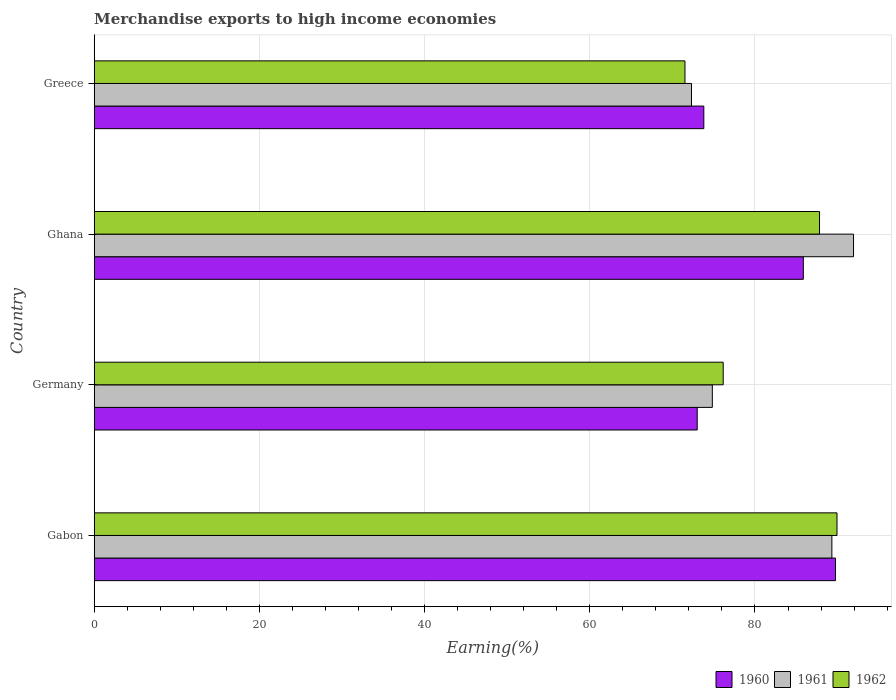What is the percentage of amount earned from merchandise exports in 1961 in Ghana?
Offer a very short reply. 91.93. Across all countries, what is the maximum percentage of amount earned from merchandise exports in 1962?
Provide a succinct answer. 89.93. Across all countries, what is the minimum percentage of amount earned from merchandise exports in 1961?
Your answer should be very brief. 72.31. In which country was the percentage of amount earned from merchandise exports in 1960 maximum?
Offer a very short reply. Gabon. What is the total percentage of amount earned from merchandise exports in 1960 in the graph?
Provide a short and direct response. 322.42. What is the difference between the percentage of amount earned from merchandise exports in 1960 in Germany and that in Greece?
Your answer should be compact. -0.8. What is the difference between the percentage of amount earned from merchandise exports in 1960 in Ghana and the percentage of amount earned from merchandise exports in 1961 in Gabon?
Offer a terse response. -3.46. What is the average percentage of amount earned from merchandise exports in 1962 per country?
Make the answer very short. 81.36. What is the difference between the percentage of amount earned from merchandise exports in 1960 and percentage of amount earned from merchandise exports in 1962 in Greece?
Provide a succinct answer. 2.28. In how many countries, is the percentage of amount earned from merchandise exports in 1961 greater than 28 %?
Provide a short and direct response. 4. What is the ratio of the percentage of amount earned from merchandise exports in 1962 in Germany to that in Ghana?
Provide a succinct answer. 0.87. Is the percentage of amount earned from merchandise exports in 1960 in Gabon less than that in Germany?
Your response must be concise. No. What is the difference between the highest and the second highest percentage of amount earned from merchandise exports in 1961?
Provide a succinct answer. 2.62. What is the difference between the highest and the lowest percentage of amount earned from merchandise exports in 1962?
Offer a terse response. 18.41. In how many countries, is the percentage of amount earned from merchandise exports in 1962 greater than the average percentage of amount earned from merchandise exports in 1962 taken over all countries?
Offer a terse response. 2. What does the 2nd bar from the bottom in Gabon represents?
Ensure brevity in your answer.  1961. Is it the case that in every country, the sum of the percentage of amount earned from merchandise exports in 1962 and percentage of amount earned from merchandise exports in 1961 is greater than the percentage of amount earned from merchandise exports in 1960?
Your response must be concise. Yes. How many bars are there?
Your answer should be very brief. 12. How many countries are there in the graph?
Keep it short and to the point. 4. How many legend labels are there?
Your answer should be very brief. 3. What is the title of the graph?
Make the answer very short. Merchandise exports to high income economies. What is the label or title of the X-axis?
Make the answer very short. Earning(%). What is the label or title of the Y-axis?
Provide a succinct answer. Country. What is the Earning(%) in 1960 in Gabon?
Make the answer very short. 89.75. What is the Earning(%) in 1961 in Gabon?
Your response must be concise. 89.31. What is the Earning(%) in 1962 in Gabon?
Your answer should be very brief. 89.93. What is the Earning(%) of 1960 in Germany?
Your answer should be very brief. 73.01. What is the Earning(%) of 1961 in Germany?
Give a very brief answer. 74.84. What is the Earning(%) of 1962 in Germany?
Your answer should be compact. 76.15. What is the Earning(%) in 1960 in Ghana?
Ensure brevity in your answer.  85.85. What is the Earning(%) in 1961 in Ghana?
Keep it short and to the point. 91.93. What is the Earning(%) in 1962 in Ghana?
Offer a terse response. 87.82. What is the Earning(%) of 1960 in Greece?
Offer a very short reply. 73.81. What is the Earning(%) of 1961 in Greece?
Provide a succinct answer. 72.31. What is the Earning(%) of 1962 in Greece?
Provide a succinct answer. 71.53. Across all countries, what is the maximum Earning(%) of 1960?
Provide a short and direct response. 89.75. Across all countries, what is the maximum Earning(%) in 1961?
Provide a succinct answer. 91.93. Across all countries, what is the maximum Earning(%) of 1962?
Provide a succinct answer. 89.93. Across all countries, what is the minimum Earning(%) in 1960?
Ensure brevity in your answer.  73.01. Across all countries, what is the minimum Earning(%) in 1961?
Ensure brevity in your answer.  72.31. Across all countries, what is the minimum Earning(%) in 1962?
Provide a short and direct response. 71.53. What is the total Earning(%) of 1960 in the graph?
Provide a succinct answer. 322.42. What is the total Earning(%) of 1961 in the graph?
Give a very brief answer. 328.4. What is the total Earning(%) of 1962 in the graph?
Provide a succinct answer. 325.43. What is the difference between the Earning(%) of 1960 in Gabon and that in Germany?
Make the answer very short. 16.74. What is the difference between the Earning(%) in 1961 in Gabon and that in Germany?
Your response must be concise. 14.47. What is the difference between the Earning(%) of 1962 in Gabon and that in Germany?
Offer a terse response. 13.78. What is the difference between the Earning(%) of 1960 in Gabon and that in Ghana?
Give a very brief answer. 3.89. What is the difference between the Earning(%) of 1961 in Gabon and that in Ghana?
Your answer should be very brief. -2.62. What is the difference between the Earning(%) of 1962 in Gabon and that in Ghana?
Your answer should be compact. 2.11. What is the difference between the Earning(%) of 1960 in Gabon and that in Greece?
Keep it short and to the point. 15.94. What is the difference between the Earning(%) of 1961 in Gabon and that in Greece?
Your response must be concise. 17. What is the difference between the Earning(%) of 1962 in Gabon and that in Greece?
Keep it short and to the point. 18.41. What is the difference between the Earning(%) of 1960 in Germany and that in Ghana?
Provide a succinct answer. -12.85. What is the difference between the Earning(%) of 1961 in Germany and that in Ghana?
Keep it short and to the point. -17.09. What is the difference between the Earning(%) of 1962 in Germany and that in Ghana?
Keep it short and to the point. -11.66. What is the difference between the Earning(%) in 1960 in Germany and that in Greece?
Ensure brevity in your answer.  -0.8. What is the difference between the Earning(%) of 1961 in Germany and that in Greece?
Your answer should be compact. 2.52. What is the difference between the Earning(%) in 1962 in Germany and that in Greece?
Offer a very short reply. 4.63. What is the difference between the Earning(%) in 1960 in Ghana and that in Greece?
Your answer should be very brief. 12.05. What is the difference between the Earning(%) in 1961 in Ghana and that in Greece?
Provide a short and direct response. 19.62. What is the difference between the Earning(%) in 1962 in Ghana and that in Greece?
Your answer should be very brief. 16.29. What is the difference between the Earning(%) of 1960 in Gabon and the Earning(%) of 1961 in Germany?
Your answer should be very brief. 14.91. What is the difference between the Earning(%) of 1960 in Gabon and the Earning(%) of 1962 in Germany?
Provide a succinct answer. 13.59. What is the difference between the Earning(%) of 1961 in Gabon and the Earning(%) of 1962 in Germany?
Keep it short and to the point. 13.16. What is the difference between the Earning(%) of 1960 in Gabon and the Earning(%) of 1961 in Ghana?
Provide a short and direct response. -2.18. What is the difference between the Earning(%) in 1960 in Gabon and the Earning(%) in 1962 in Ghana?
Offer a very short reply. 1.93. What is the difference between the Earning(%) of 1961 in Gabon and the Earning(%) of 1962 in Ghana?
Make the answer very short. 1.49. What is the difference between the Earning(%) in 1960 in Gabon and the Earning(%) in 1961 in Greece?
Keep it short and to the point. 17.43. What is the difference between the Earning(%) of 1960 in Gabon and the Earning(%) of 1962 in Greece?
Your answer should be compact. 18.22. What is the difference between the Earning(%) in 1961 in Gabon and the Earning(%) in 1962 in Greece?
Give a very brief answer. 17.79. What is the difference between the Earning(%) in 1960 in Germany and the Earning(%) in 1961 in Ghana?
Ensure brevity in your answer.  -18.93. What is the difference between the Earning(%) in 1960 in Germany and the Earning(%) in 1962 in Ghana?
Your answer should be very brief. -14.81. What is the difference between the Earning(%) of 1961 in Germany and the Earning(%) of 1962 in Ghana?
Ensure brevity in your answer.  -12.98. What is the difference between the Earning(%) of 1960 in Germany and the Earning(%) of 1961 in Greece?
Your answer should be very brief. 0.69. What is the difference between the Earning(%) of 1960 in Germany and the Earning(%) of 1962 in Greece?
Provide a short and direct response. 1.48. What is the difference between the Earning(%) of 1961 in Germany and the Earning(%) of 1962 in Greece?
Offer a very short reply. 3.31. What is the difference between the Earning(%) of 1960 in Ghana and the Earning(%) of 1961 in Greece?
Your answer should be compact. 13.54. What is the difference between the Earning(%) in 1960 in Ghana and the Earning(%) in 1962 in Greece?
Give a very brief answer. 14.33. What is the difference between the Earning(%) in 1961 in Ghana and the Earning(%) in 1962 in Greece?
Your response must be concise. 20.41. What is the average Earning(%) in 1960 per country?
Make the answer very short. 80.6. What is the average Earning(%) in 1961 per country?
Make the answer very short. 82.1. What is the average Earning(%) in 1962 per country?
Your answer should be very brief. 81.36. What is the difference between the Earning(%) of 1960 and Earning(%) of 1961 in Gabon?
Keep it short and to the point. 0.44. What is the difference between the Earning(%) in 1960 and Earning(%) in 1962 in Gabon?
Provide a short and direct response. -0.18. What is the difference between the Earning(%) of 1961 and Earning(%) of 1962 in Gabon?
Make the answer very short. -0.62. What is the difference between the Earning(%) in 1960 and Earning(%) in 1961 in Germany?
Ensure brevity in your answer.  -1.83. What is the difference between the Earning(%) in 1960 and Earning(%) in 1962 in Germany?
Provide a short and direct response. -3.15. What is the difference between the Earning(%) of 1961 and Earning(%) of 1962 in Germany?
Keep it short and to the point. -1.32. What is the difference between the Earning(%) of 1960 and Earning(%) of 1961 in Ghana?
Give a very brief answer. -6.08. What is the difference between the Earning(%) in 1960 and Earning(%) in 1962 in Ghana?
Make the answer very short. -1.96. What is the difference between the Earning(%) in 1961 and Earning(%) in 1962 in Ghana?
Your response must be concise. 4.12. What is the difference between the Earning(%) of 1960 and Earning(%) of 1961 in Greece?
Your answer should be compact. 1.49. What is the difference between the Earning(%) in 1960 and Earning(%) in 1962 in Greece?
Give a very brief answer. 2.28. What is the difference between the Earning(%) in 1961 and Earning(%) in 1962 in Greece?
Keep it short and to the point. 0.79. What is the ratio of the Earning(%) of 1960 in Gabon to that in Germany?
Make the answer very short. 1.23. What is the ratio of the Earning(%) in 1961 in Gabon to that in Germany?
Your response must be concise. 1.19. What is the ratio of the Earning(%) in 1962 in Gabon to that in Germany?
Provide a short and direct response. 1.18. What is the ratio of the Earning(%) in 1960 in Gabon to that in Ghana?
Your response must be concise. 1.05. What is the ratio of the Earning(%) in 1961 in Gabon to that in Ghana?
Provide a succinct answer. 0.97. What is the ratio of the Earning(%) of 1962 in Gabon to that in Ghana?
Your response must be concise. 1.02. What is the ratio of the Earning(%) of 1960 in Gabon to that in Greece?
Provide a short and direct response. 1.22. What is the ratio of the Earning(%) in 1961 in Gabon to that in Greece?
Provide a short and direct response. 1.24. What is the ratio of the Earning(%) of 1962 in Gabon to that in Greece?
Your answer should be very brief. 1.26. What is the ratio of the Earning(%) in 1960 in Germany to that in Ghana?
Provide a succinct answer. 0.85. What is the ratio of the Earning(%) in 1961 in Germany to that in Ghana?
Give a very brief answer. 0.81. What is the ratio of the Earning(%) of 1962 in Germany to that in Ghana?
Offer a very short reply. 0.87. What is the ratio of the Earning(%) of 1960 in Germany to that in Greece?
Provide a short and direct response. 0.99. What is the ratio of the Earning(%) in 1961 in Germany to that in Greece?
Offer a very short reply. 1.03. What is the ratio of the Earning(%) in 1962 in Germany to that in Greece?
Make the answer very short. 1.06. What is the ratio of the Earning(%) of 1960 in Ghana to that in Greece?
Keep it short and to the point. 1.16. What is the ratio of the Earning(%) in 1961 in Ghana to that in Greece?
Offer a terse response. 1.27. What is the ratio of the Earning(%) of 1962 in Ghana to that in Greece?
Provide a short and direct response. 1.23. What is the difference between the highest and the second highest Earning(%) of 1960?
Offer a terse response. 3.89. What is the difference between the highest and the second highest Earning(%) in 1961?
Offer a very short reply. 2.62. What is the difference between the highest and the second highest Earning(%) of 1962?
Your answer should be compact. 2.11. What is the difference between the highest and the lowest Earning(%) of 1960?
Ensure brevity in your answer.  16.74. What is the difference between the highest and the lowest Earning(%) of 1961?
Give a very brief answer. 19.62. What is the difference between the highest and the lowest Earning(%) of 1962?
Your answer should be very brief. 18.41. 